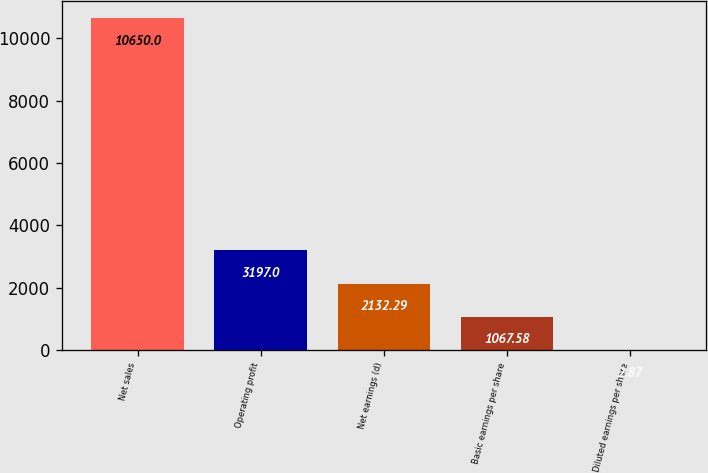Convert chart. <chart><loc_0><loc_0><loc_500><loc_500><bar_chart><fcel>Net sales<fcel>Operating profit<fcel>Net earnings (d)<fcel>Basic earnings per share<fcel>Diluted earnings per share<nl><fcel>10650<fcel>3197<fcel>2132.29<fcel>1067.58<fcel>2.87<nl></chart> 